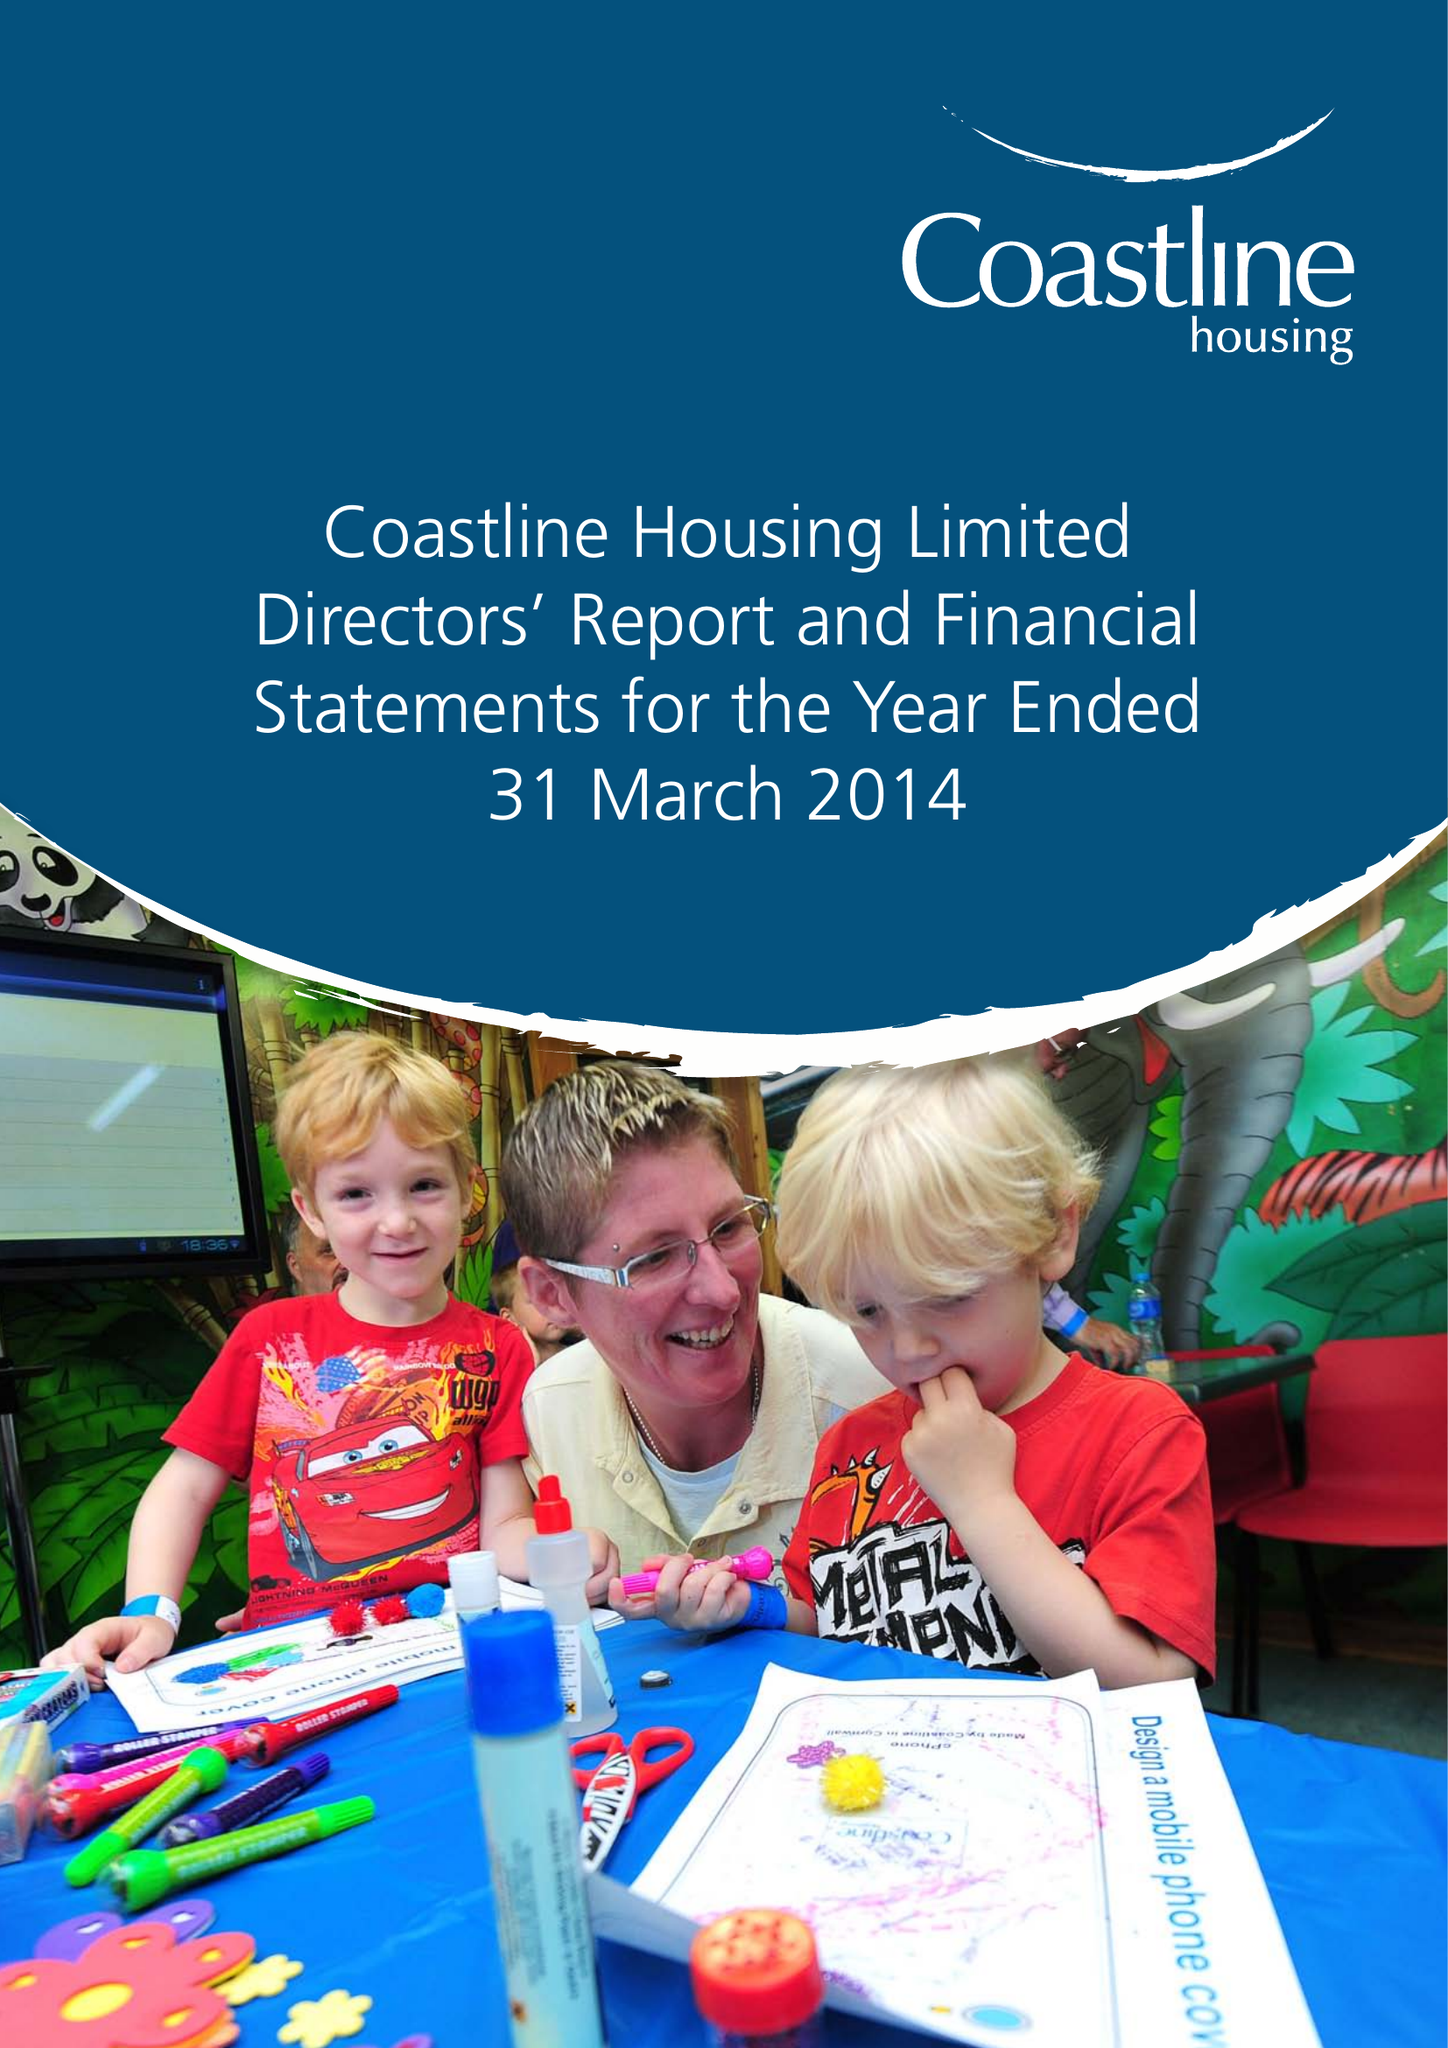What is the value for the charity_name?
Answer the question using a single word or phrase. Coastline Housing Ltd. 